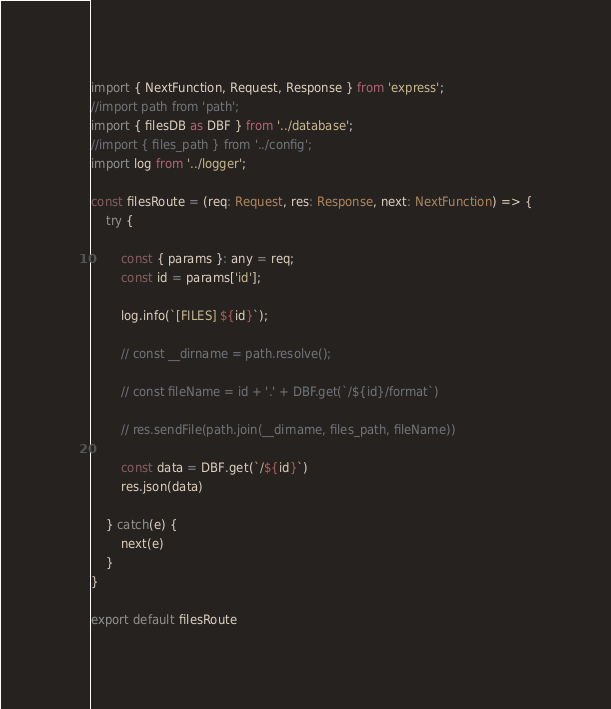Convert code to text. <code><loc_0><loc_0><loc_500><loc_500><_TypeScript_>import { NextFunction, Request, Response } from 'express';
//import path from 'path';
import { filesDB as DBF } from '../database';
//import { files_path } from '../config';
import log from '../logger';

const filesRoute = (req: Request, res: Response, next: NextFunction) => {
    try {

        const { params }: any = req;
        const id = params['id'];
    
        log.info(`[FILES] ${id}`);
        
        // const __dirname = path.resolve();
    
        // const fileName = id + '.' + DBF.get(`/${id}/format`)
    
        // res.sendFile(path.join(__dirname, files_path, fileName))

        const data = DBF.get(`/${id}`)
        res.json(data)
        
    } catch(e) {
        next(e)
    }
}

export default filesRoute</code> 